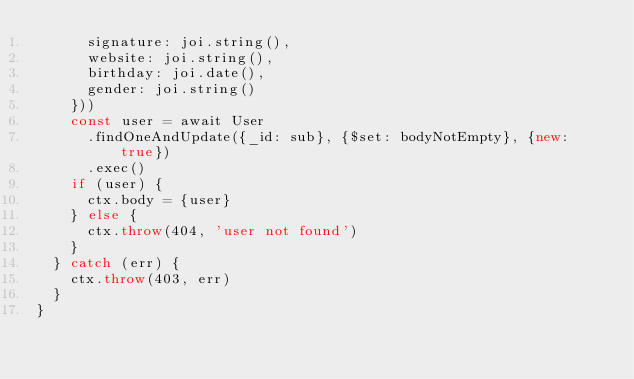Convert code to text. <code><loc_0><loc_0><loc_500><loc_500><_JavaScript_>      signature: joi.string(),
      website: joi.string(),
      birthday: joi.date(),
      gender: joi.string()
    }))
    const user = await User
      .findOneAndUpdate({_id: sub}, {$set: bodyNotEmpty}, {new: true})
      .exec()
    if (user) {
      ctx.body = {user}
    } else {
      ctx.throw(404, 'user not found')
    }
  } catch (err) {
    ctx.throw(403, err)
  }
}
</code> 